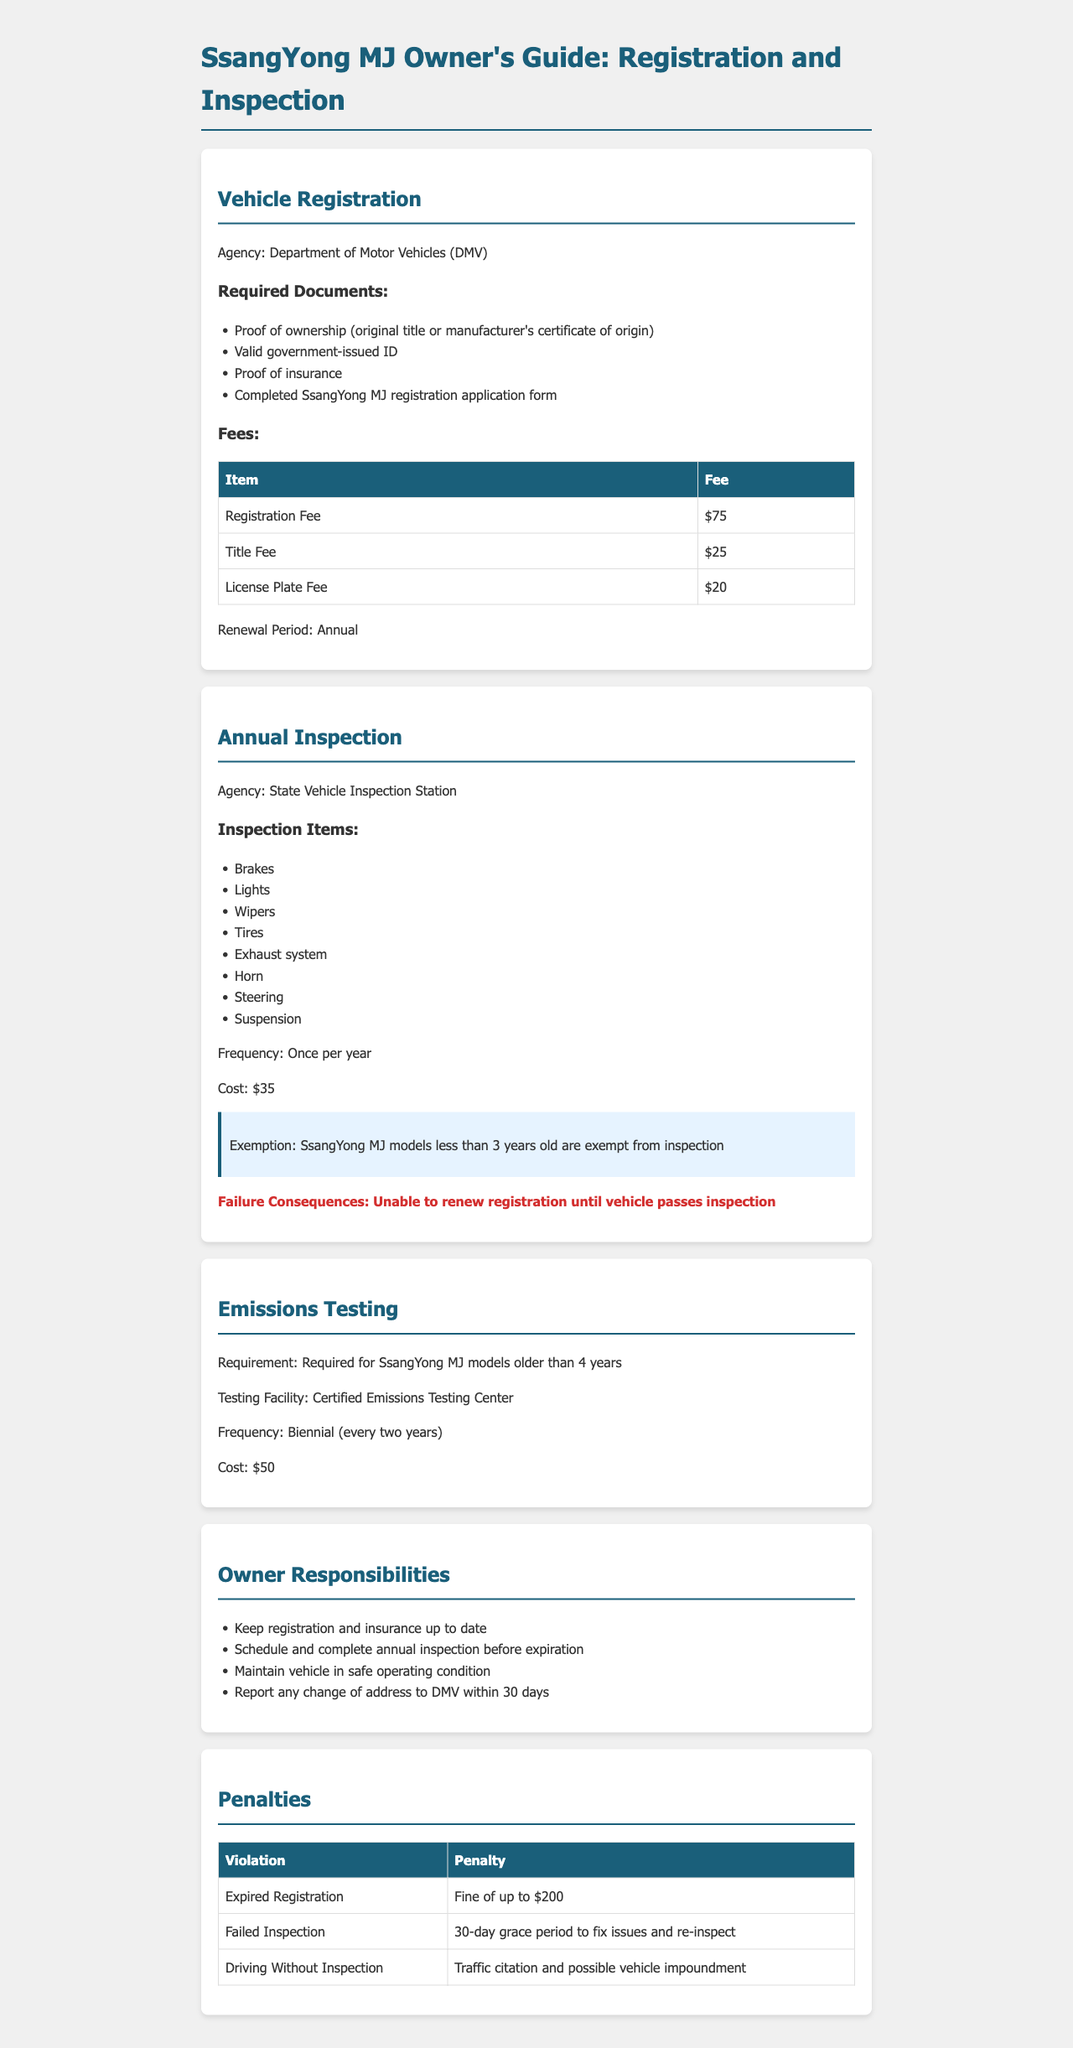What is the agency responsible for vehicle registration? The agency listed for vehicle registration is the Department of Motor Vehicles (DMV).
Answer: Department of Motor Vehicles (DMV) What is the registration fee for the SsangYong MJ? The registration fee is specifically stated in the document as $75.
Answer: $75 How often must the annual inspection be completed? The document states that the annual inspection must be completed once per year.
Answer: Once per year What is the cost of the annual inspection? The cost for the annual inspection is mentioned as $35 in the document.
Answer: $35 Are SsangYong MJ models less than 3 years old required to undergo inspection? The document clearly states the exemption for models less than 3 years old from inspection.
Answer: Yes What happens if the vehicle fails inspection? The document indicates that failing inspection results in an inability to renew registration until the vehicle passes.
Answer: Unable to renew registration What is the consequence of having an expired registration? According to the document, the penalty for expired registration is a fine of up to $200.
Answer: Fine of up to $200 How often is emissions testing required for older SsangYong MJ models? The document specifies that emissions testing is required biennially for models older than 4 years.
Answer: Biennial What should owners report to the DMV within 30 days? The document states that owners must report any change of address to the DMV.
Answer: Change of address 